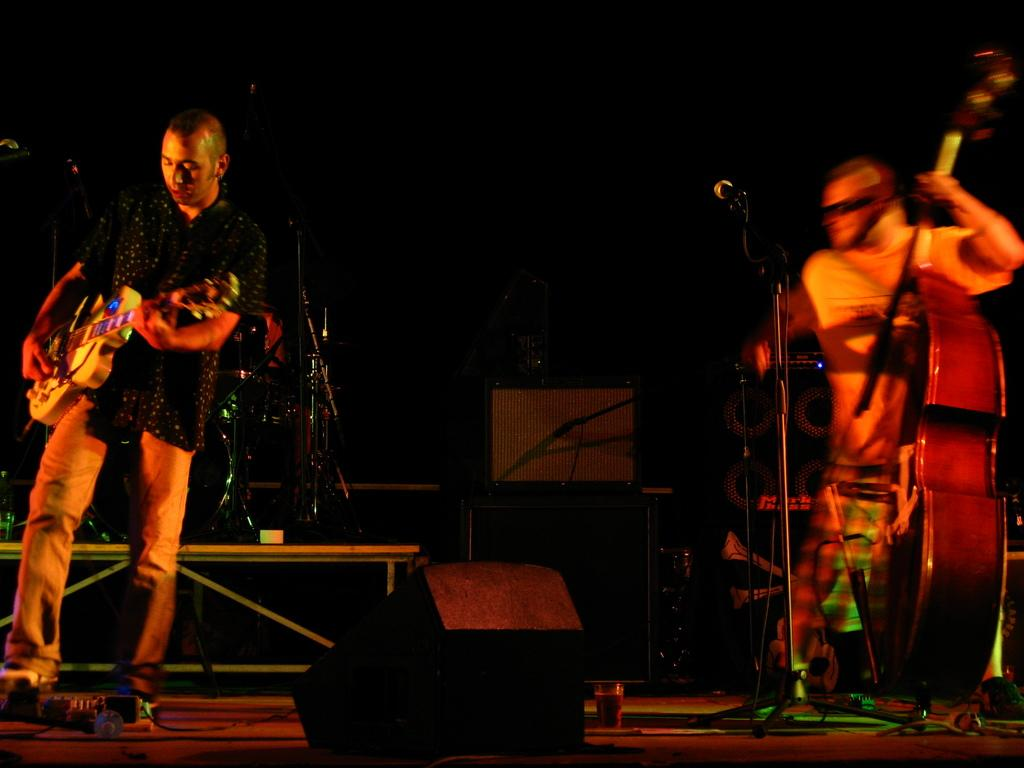How many people are in the image? There are two people in the image. What are the two people doing in the image? The two people are holding musical instruments. What can be seen on the stage in the image? There is a microphone (mic) on the stage. What type of water is being used to process the musical instruments in the image? There is no water or processing of musical instruments visible in the image. 